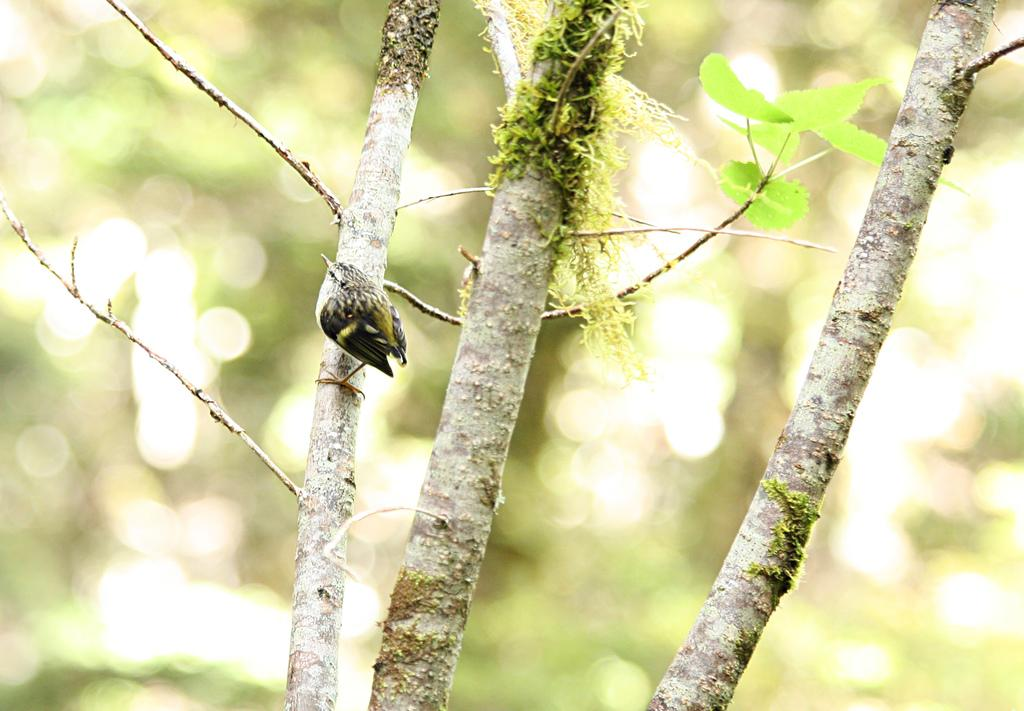What is the main subject in the center of the image? There is a bird in the center of the image. What type of plant can be seen in the image? There is a tree in the image. What is covering the tree and possibly other parts of the image? Leaves are present in the image. How would you describe the overall appearance of the image? The background of the image is blurry. How much pleasure does the bird derive from the dime in the image? There is no dime present in the image, and therefore no pleasure can be derived from it. 